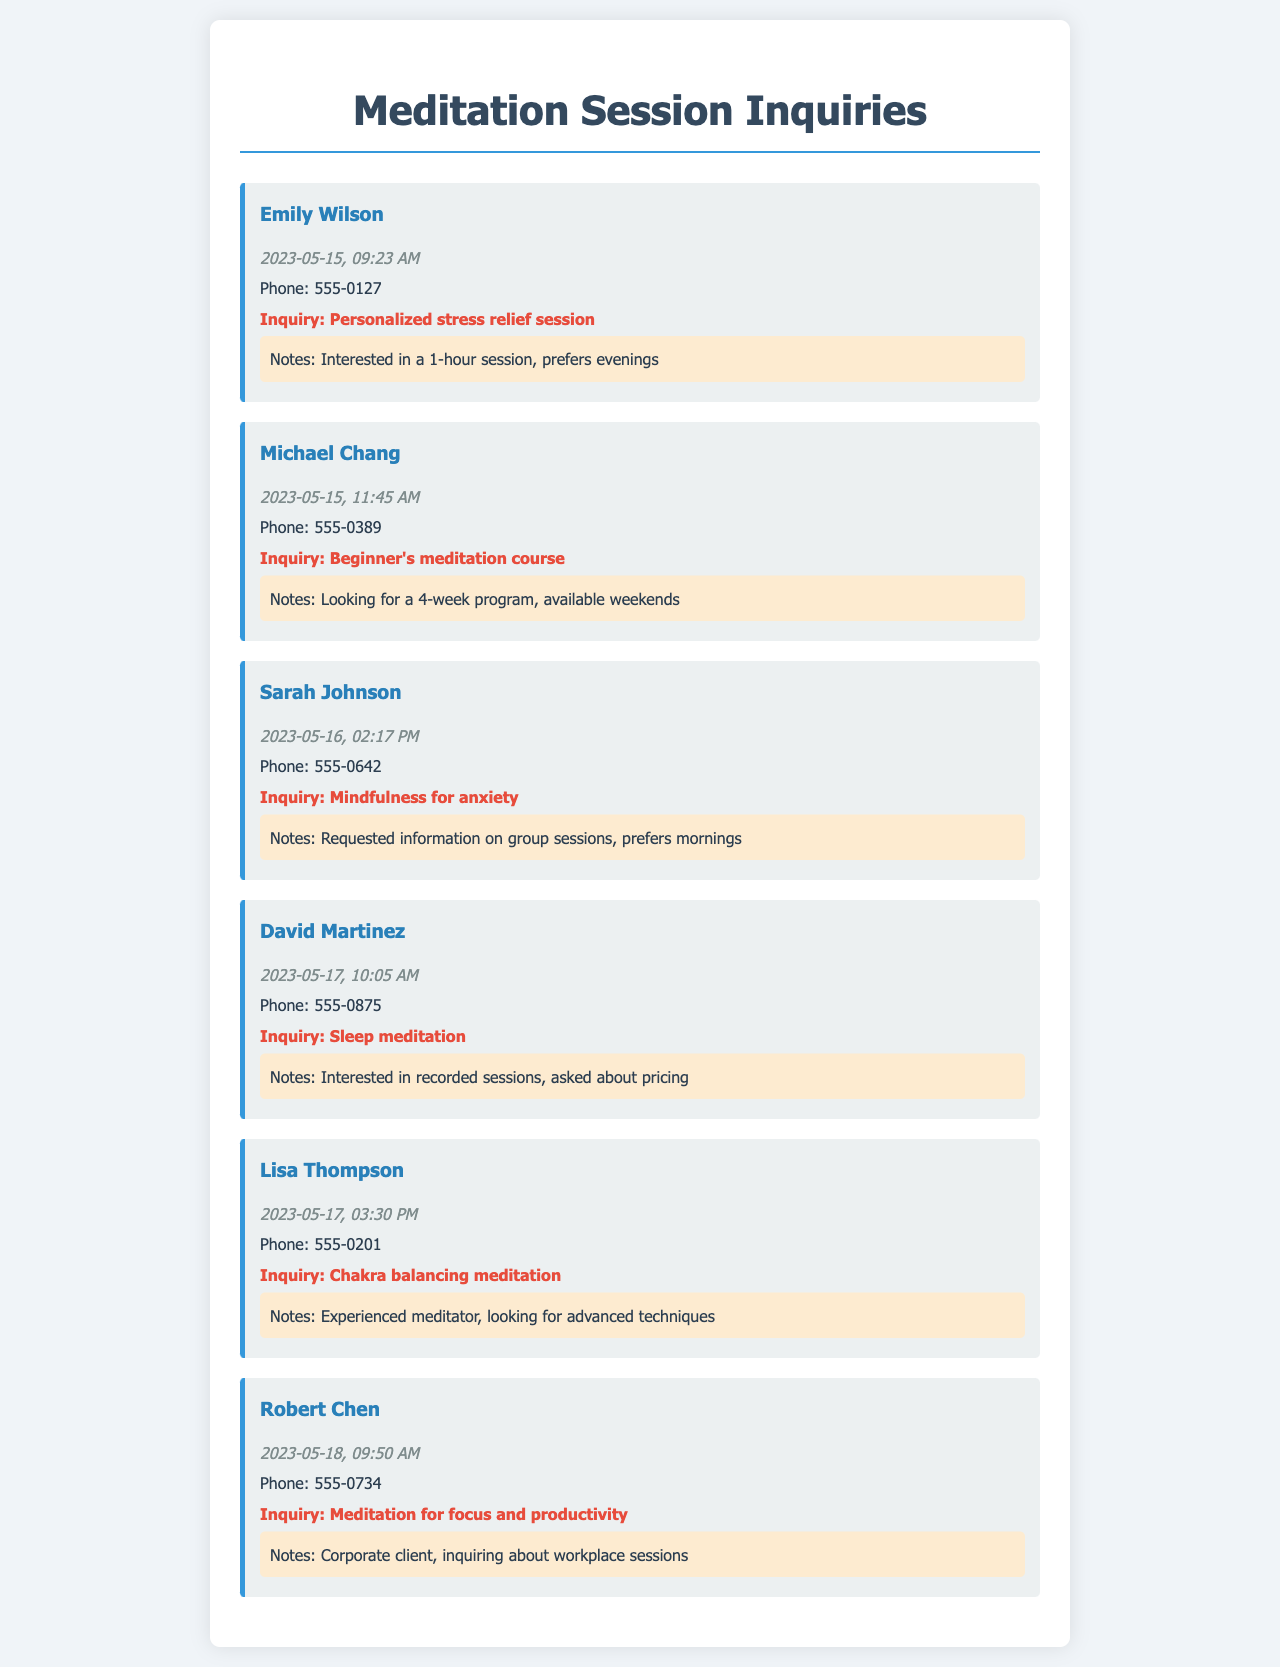What is the name of the first student? The name of the first student listed in the document is Emily Wilson.
Answer: Emily Wilson What did Michael Chang inquire about? Michael Chang inquired about a beginner's meditation course.
Answer: Beginner's meditation course On what date did Sarah Johnson call? Sarah Johnson called on May 16, 2023.
Answer: 2023-05-16 What type of session is David Martinez interested in? David Martinez is interested in sleep meditation.
Answer: Sleep meditation How long does Lisa Thompson have experience in meditation? Lisa Thompson is an experienced meditator.
Answer: Experienced Which student prefers morning sessions? Sarah Johnson prefers morning sessions.
Answer: Sarah Johnson How many students are interested in a group session? One student, Sarah Johnson, requested information on group sessions.
Answer: One What time did Robert Chen call? Robert Chen called at 9:50 AM.
Answer: 09:50 AM What is the contact number for Emily Wilson? The contact number for Emily Wilson is 555-0127.
Answer: 555-0127 